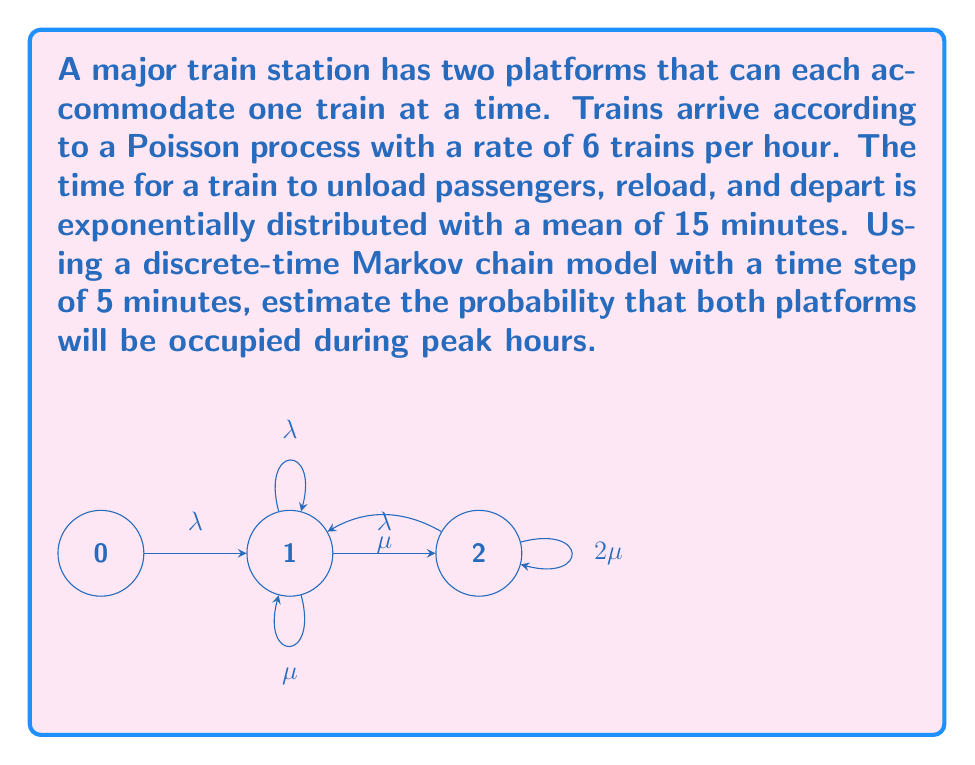Show me your answer to this math problem. To solve this problem, we'll follow these steps:

1) First, let's define our parameters:
   $\lambda$ = arrival rate = 6 trains/hour = 0.5 trains/5 minutes
   $\mu$ = service rate = 4 trains/hour = 1/3 trains/5 minutes

2) The state transition probabilities for our Markov chain are:
   $p_{01} = \lambda e^{-\lambda}$
   $p_{12} = \lambda e^{-\lambda}$
   $p_{10} = \mu e^{-\lambda}$
   $p_{11} = \lambda e^{-\lambda} + \mu e^{-\lambda}$
   $p_{21} = 2\mu e^{-\lambda}$
   $p_{22} = 1 - 2\mu e^{-\lambda}$

3) We can write the transition matrix P:

   $$P = \begin{bmatrix}
   e^{-\lambda} & \lambda e^{-\lambda} & 0 \\
   \mu e^{-\lambda} & \lambda e^{-\lambda} + \mu e^{-\lambda} & \lambda e^{-\lambda} \\
   0 & 2\mu e^{-\lambda} & 1 - 2\mu e^{-\lambda}
   \end{bmatrix}$$

4) The steady-state probabilities $\pi = [\pi_0, \pi_1, \pi_2]$ satisfy $\pi P = \pi$ and $\sum \pi_i = 1$

5) Solving this system of equations:

   $$\begin{cases}
   \pi_0 = \pi_0 e^{-\lambda} + \pi_1 \mu e^{-\lambda} \\
   \pi_1 = \pi_0 \lambda e^{-\lambda} + \pi_1 (\lambda e^{-\lambda} + \mu e^{-\lambda}) + \pi_2 2\mu e^{-\lambda} \\
   \pi_2 = \pi_1 \lambda e^{-\lambda} + \pi_2 (1 - 2\mu e^{-\lambda}) \\
   \pi_0 + \pi_1 + \pi_2 = 1
   \end{cases}$$

6) Substituting our values and solving numerically:

   $$\begin{cases}
   \pi_0 \approx 0.1353 \\
   \pi_1 \approx 0.4059 \\
   \pi_2 \approx 0.4588
   \end{cases}$$

7) The probability that both platforms are occupied is $\pi_2 \approx 0.4588$ or about 45.88%.
Answer: 0.4588 or 45.88% 